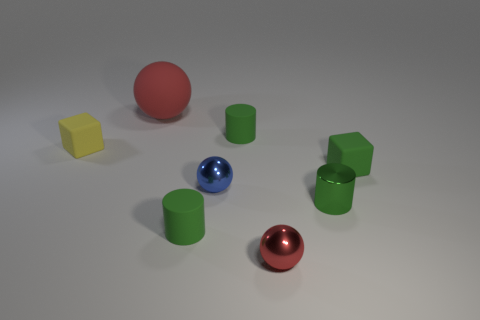There is a small rubber object that is behind the yellow thing; is its color the same as the rubber ball?
Keep it short and to the point. No. There is a green matte object that is behind the object that is left of the big red rubber object; what shape is it?
Your response must be concise. Cylinder. Is there a metallic thing of the same size as the blue metallic ball?
Your response must be concise. Yes. Are there fewer yellow matte cubes than green cylinders?
Your answer should be very brief. Yes. What is the shape of the object that is right of the small metallic thing that is on the right side of the red thing that is in front of the large matte thing?
Offer a terse response. Cube. How many things are objects that are in front of the metal cylinder or shiny things that are right of the tiny blue shiny object?
Keep it short and to the point. 3. There is a tiny blue metal thing; are there any tiny matte things in front of it?
Keep it short and to the point. Yes. What number of objects are either yellow rubber objects that are in front of the red rubber thing or yellow metal objects?
Provide a succinct answer. 1. What number of blue things are matte cubes or small cylinders?
Make the answer very short. 0. How many other objects are the same color as the rubber sphere?
Ensure brevity in your answer.  1. 